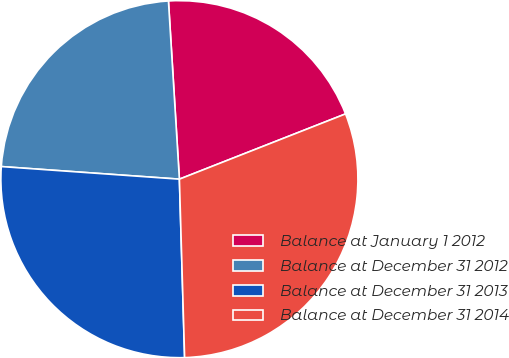Convert chart. <chart><loc_0><loc_0><loc_500><loc_500><pie_chart><fcel>Balance at January 1 2012<fcel>Balance at December 31 2012<fcel>Balance at December 31 2013<fcel>Balance at December 31 2014<nl><fcel>20.02%<fcel>22.9%<fcel>26.59%<fcel>30.49%<nl></chart> 